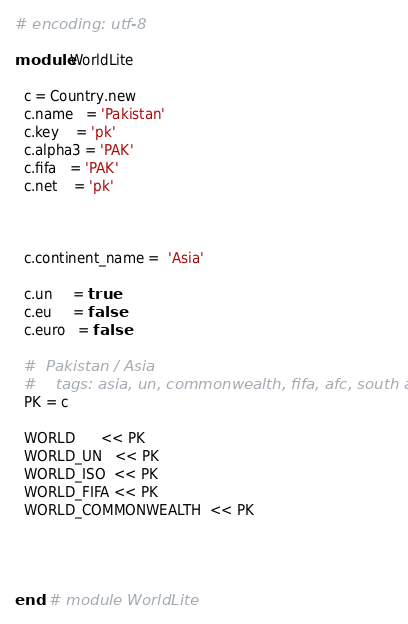Convert code to text. <code><loc_0><loc_0><loc_500><loc_500><_Ruby_># encoding: utf-8

module WorldLite

  c = Country.new
  c.name   = 'Pakistan'
  c.key    = 'pk'
  c.alpha3 = 'PAK'
  c.fifa   = 'PAK'
  c.net    = 'pk'



  c.continent_name =  'Asia'

  c.un     = true
  c.eu     = false
  c.euro   = false

  #  Pakistan / Asia
  #    tags: asia, un, commonwealth, fifa, afc, south asia
  PK = c

  WORLD      << PK
  WORLD_UN   << PK
  WORLD_ISO  << PK
  WORLD_FIFA << PK
  WORLD_COMMONWEALTH  << PK




end  # module WorldLite
</code> 